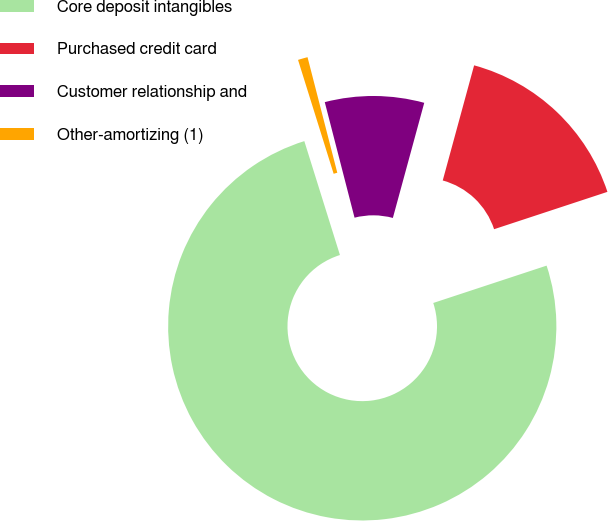Convert chart to OTSL. <chart><loc_0><loc_0><loc_500><loc_500><pie_chart><fcel>Core deposit intangibles<fcel>Purchased credit card<fcel>Customer relationship and<fcel>Other-amortizing (1)<nl><fcel>75.25%<fcel>15.7%<fcel>8.25%<fcel>0.81%<nl></chart> 